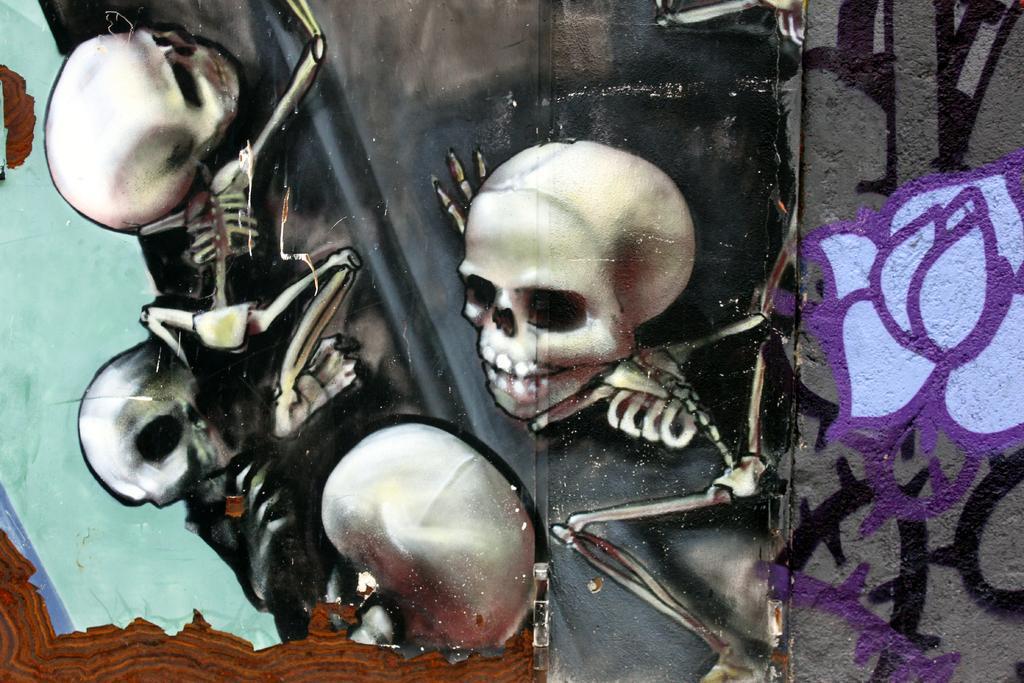How would you summarize this image in a sentence or two? In this image I can see few skulls and I can also see the wall painting and the painting is in purple and black color. 